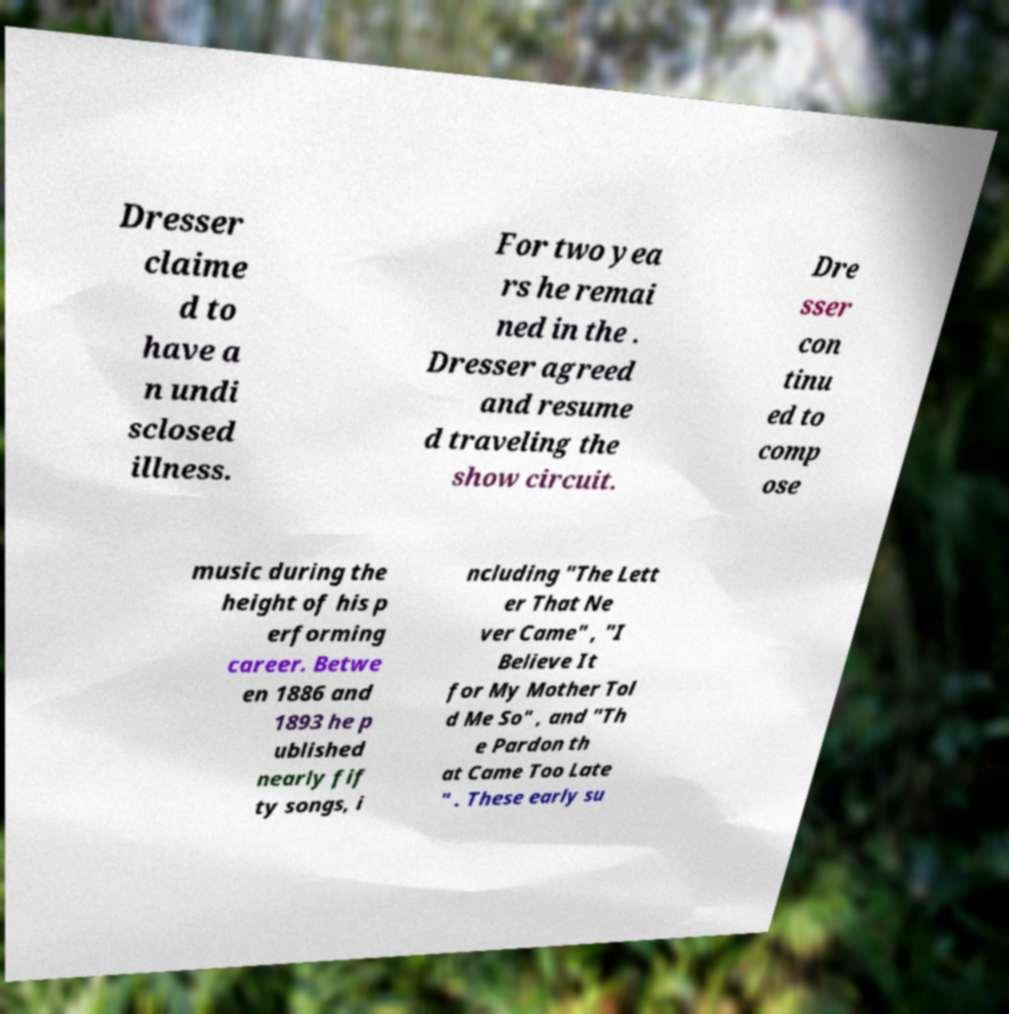Can you read and provide the text displayed in the image?This photo seems to have some interesting text. Can you extract and type it out for me? Dresser claime d to have a n undi sclosed illness. For two yea rs he remai ned in the . Dresser agreed and resume d traveling the show circuit. Dre sser con tinu ed to comp ose music during the height of his p erforming career. Betwe en 1886 and 1893 he p ublished nearly fif ty songs, i ncluding "The Lett er That Ne ver Came" , "I Believe It for My Mother Tol d Me So" , and "Th e Pardon th at Came Too Late " . These early su 